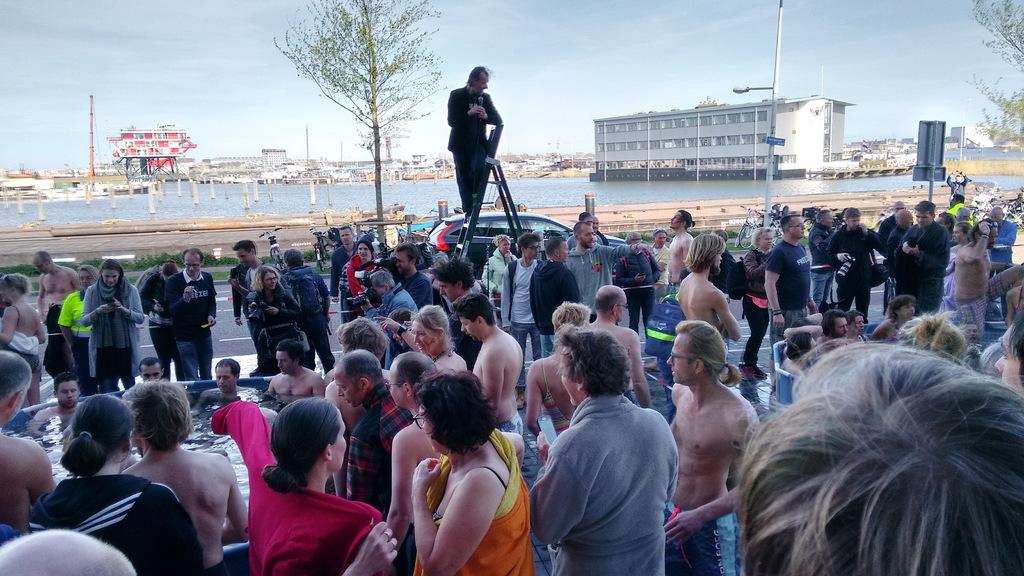Who or what can be seen in the image? There are people in the image. What can be seen in the distance behind the people? There is water, buildings, and the sky visible in the background of the image. What type of cannon is being fired in the image? There is no cannon present in the image. Can you tell me the time on the clock in the image? There is no clock present in the image. 